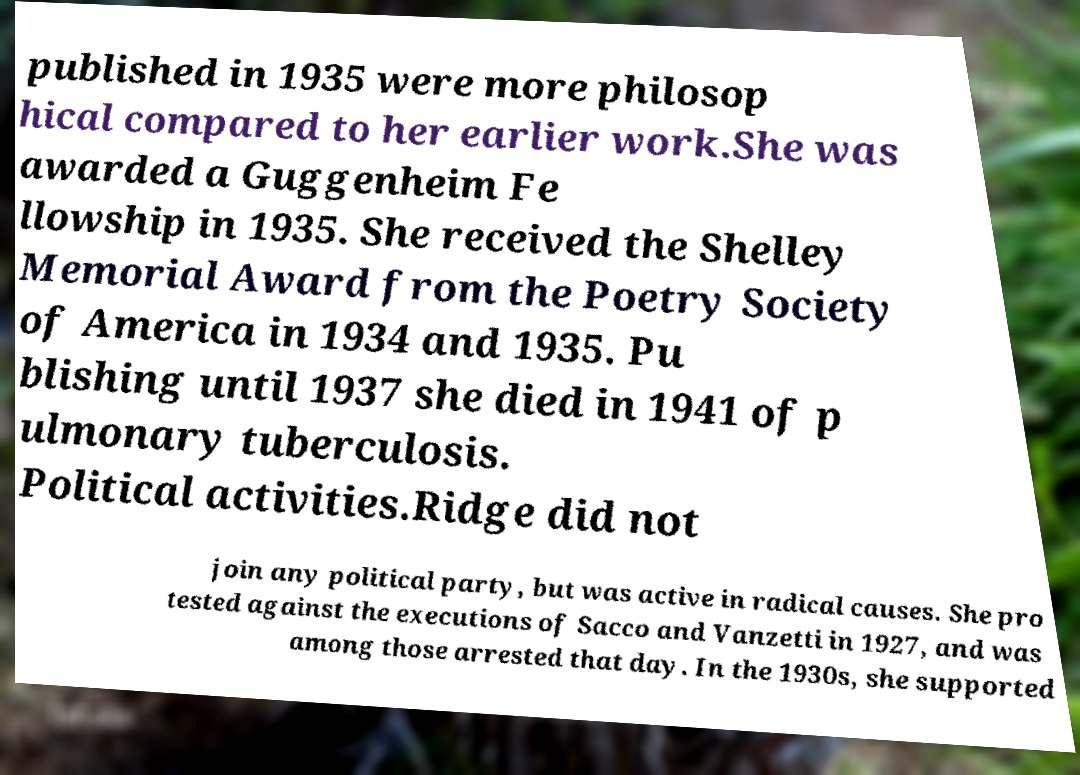Please identify and transcribe the text found in this image. published in 1935 were more philosop hical compared to her earlier work.She was awarded a Guggenheim Fe llowship in 1935. She received the Shelley Memorial Award from the Poetry Society of America in 1934 and 1935. Pu blishing until 1937 she died in 1941 of p ulmonary tuberculosis. Political activities.Ridge did not join any political party, but was active in radical causes. She pro tested against the executions of Sacco and Vanzetti in 1927, and was among those arrested that day. In the 1930s, she supported 